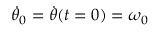Convert formula to latex. <formula><loc_0><loc_0><loc_500><loc_500>\ D o t { \theta } _ { 0 } = \ D o t { \theta } ( t = 0 ) = \omega _ { 0 }</formula> 